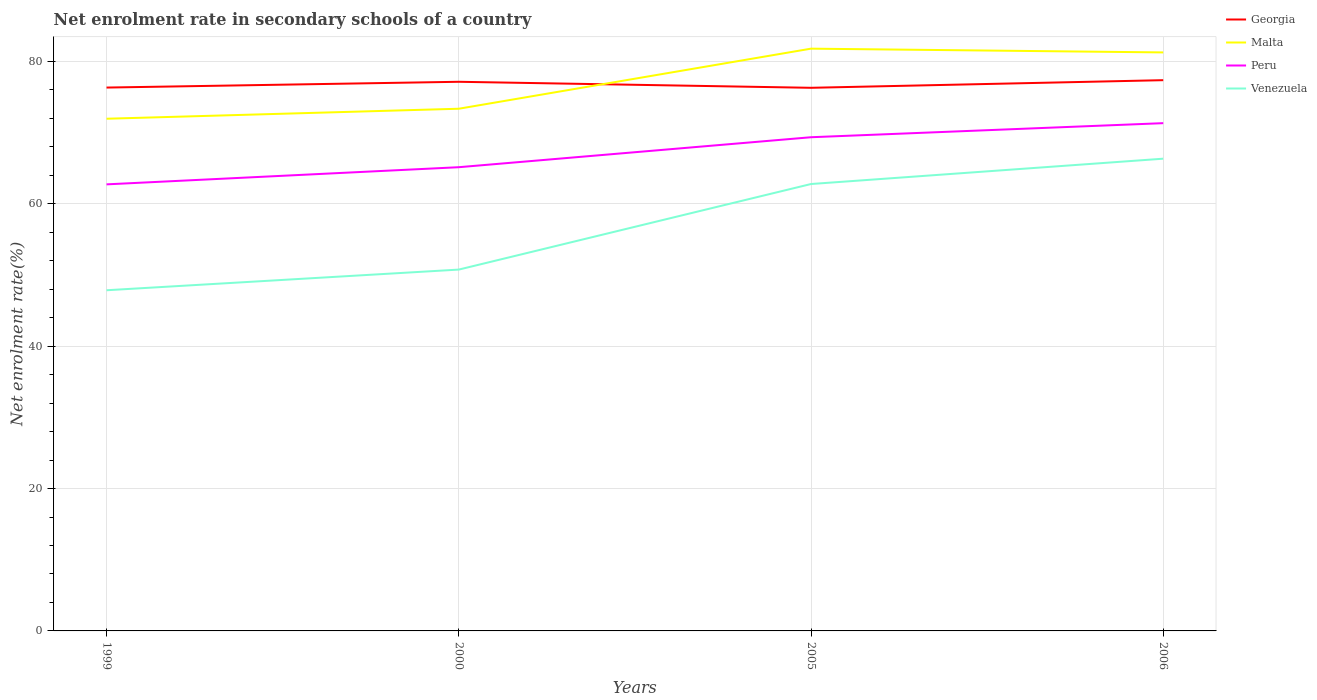How many different coloured lines are there?
Provide a short and direct response. 4. Does the line corresponding to Venezuela intersect with the line corresponding to Malta?
Your response must be concise. No. Across all years, what is the maximum net enrolment rate in secondary schools in Venezuela?
Offer a very short reply. 47.85. In which year was the net enrolment rate in secondary schools in Venezuela maximum?
Give a very brief answer. 1999. What is the total net enrolment rate in secondary schools in Malta in the graph?
Give a very brief answer. -8.44. What is the difference between the highest and the second highest net enrolment rate in secondary schools in Georgia?
Your response must be concise. 1.07. What is the difference between the highest and the lowest net enrolment rate in secondary schools in Georgia?
Your answer should be compact. 2. Is the net enrolment rate in secondary schools in Georgia strictly greater than the net enrolment rate in secondary schools in Malta over the years?
Offer a very short reply. No. Are the values on the major ticks of Y-axis written in scientific E-notation?
Offer a terse response. No. Does the graph contain any zero values?
Your answer should be compact. No. How are the legend labels stacked?
Keep it short and to the point. Vertical. What is the title of the graph?
Your answer should be very brief. Net enrolment rate in secondary schools of a country. Does "Rwanda" appear as one of the legend labels in the graph?
Ensure brevity in your answer.  No. What is the label or title of the X-axis?
Offer a terse response. Years. What is the label or title of the Y-axis?
Provide a short and direct response. Net enrolment rate(%). What is the Net enrolment rate(%) in Georgia in 1999?
Offer a very short reply. 76.32. What is the Net enrolment rate(%) of Malta in 1999?
Offer a very short reply. 71.94. What is the Net enrolment rate(%) in Peru in 1999?
Provide a succinct answer. 62.72. What is the Net enrolment rate(%) of Venezuela in 1999?
Provide a short and direct response. 47.85. What is the Net enrolment rate(%) in Georgia in 2000?
Make the answer very short. 77.13. What is the Net enrolment rate(%) of Malta in 2000?
Keep it short and to the point. 73.34. What is the Net enrolment rate(%) in Peru in 2000?
Keep it short and to the point. 65.13. What is the Net enrolment rate(%) of Venezuela in 2000?
Provide a short and direct response. 50.75. What is the Net enrolment rate(%) of Georgia in 2005?
Give a very brief answer. 76.28. What is the Net enrolment rate(%) in Malta in 2005?
Your answer should be very brief. 81.78. What is the Net enrolment rate(%) in Peru in 2005?
Provide a succinct answer. 69.34. What is the Net enrolment rate(%) in Venezuela in 2005?
Make the answer very short. 62.77. What is the Net enrolment rate(%) in Georgia in 2006?
Provide a short and direct response. 77.35. What is the Net enrolment rate(%) in Malta in 2006?
Make the answer very short. 81.25. What is the Net enrolment rate(%) in Peru in 2006?
Keep it short and to the point. 71.32. What is the Net enrolment rate(%) in Venezuela in 2006?
Your answer should be compact. 66.32. Across all years, what is the maximum Net enrolment rate(%) in Georgia?
Offer a terse response. 77.35. Across all years, what is the maximum Net enrolment rate(%) of Malta?
Offer a terse response. 81.78. Across all years, what is the maximum Net enrolment rate(%) in Peru?
Keep it short and to the point. 71.32. Across all years, what is the maximum Net enrolment rate(%) of Venezuela?
Your answer should be compact. 66.32. Across all years, what is the minimum Net enrolment rate(%) in Georgia?
Make the answer very short. 76.28. Across all years, what is the minimum Net enrolment rate(%) of Malta?
Offer a very short reply. 71.94. Across all years, what is the minimum Net enrolment rate(%) in Peru?
Keep it short and to the point. 62.72. Across all years, what is the minimum Net enrolment rate(%) in Venezuela?
Offer a very short reply. 47.85. What is the total Net enrolment rate(%) of Georgia in the graph?
Provide a succinct answer. 307.07. What is the total Net enrolment rate(%) of Malta in the graph?
Offer a very short reply. 308.31. What is the total Net enrolment rate(%) of Peru in the graph?
Offer a terse response. 268.5. What is the total Net enrolment rate(%) of Venezuela in the graph?
Your response must be concise. 227.69. What is the difference between the Net enrolment rate(%) in Georgia in 1999 and that in 2000?
Make the answer very short. -0.81. What is the difference between the Net enrolment rate(%) of Malta in 1999 and that in 2000?
Offer a very short reply. -1.41. What is the difference between the Net enrolment rate(%) of Peru in 1999 and that in 2000?
Keep it short and to the point. -2.41. What is the difference between the Net enrolment rate(%) of Venezuela in 1999 and that in 2000?
Your answer should be compact. -2.9. What is the difference between the Net enrolment rate(%) in Georgia in 1999 and that in 2005?
Offer a very short reply. 0.03. What is the difference between the Net enrolment rate(%) of Malta in 1999 and that in 2005?
Keep it short and to the point. -9.84. What is the difference between the Net enrolment rate(%) of Peru in 1999 and that in 2005?
Provide a short and direct response. -6.62. What is the difference between the Net enrolment rate(%) in Venezuela in 1999 and that in 2005?
Make the answer very short. -14.92. What is the difference between the Net enrolment rate(%) in Georgia in 1999 and that in 2006?
Your answer should be very brief. -1.04. What is the difference between the Net enrolment rate(%) of Malta in 1999 and that in 2006?
Ensure brevity in your answer.  -9.31. What is the difference between the Net enrolment rate(%) of Peru in 1999 and that in 2006?
Your answer should be compact. -8.6. What is the difference between the Net enrolment rate(%) of Venezuela in 1999 and that in 2006?
Make the answer very short. -18.48. What is the difference between the Net enrolment rate(%) of Georgia in 2000 and that in 2005?
Your response must be concise. 0.84. What is the difference between the Net enrolment rate(%) in Malta in 2000 and that in 2005?
Offer a very short reply. -8.44. What is the difference between the Net enrolment rate(%) of Peru in 2000 and that in 2005?
Your response must be concise. -4.21. What is the difference between the Net enrolment rate(%) in Venezuela in 2000 and that in 2005?
Ensure brevity in your answer.  -12.02. What is the difference between the Net enrolment rate(%) of Georgia in 2000 and that in 2006?
Give a very brief answer. -0.23. What is the difference between the Net enrolment rate(%) in Malta in 2000 and that in 2006?
Provide a succinct answer. -7.91. What is the difference between the Net enrolment rate(%) in Peru in 2000 and that in 2006?
Offer a very short reply. -6.19. What is the difference between the Net enrolment rate(%) of Venezuela in 2000 and that in 2006?
Make the answer very short. -15.58. What is the difference between the Net enrolment rate(%) in Georgia in 2005 and that in 2006?
Your answer should be very brief. -1.07. What is the difference between the Net enrolment rate(%) in Malta in 2005 and that in 2006?
Keep it short and to the point. 0.53. What is the difference between the Net enrolment rate(%) in Peru in 2005 and that in 2006?
Your response must be concise. -1.98. What is the difference between the Net enrolment rate(%) of Venezuela in 2005 and that in 2006?
Make the answer very short. -3.56. What is the difference between the Net enrolment rate(%) in Georgia in 1999 and the Net enrolment rate(%) in Malta in 2000?
Give a very brief answer. 2.97. What is the difference between the Net enrolment rate(%) of Georgia in 1999 and the Net enrolment rate(%) of Peru in 2000?
Ensure brevity in your answer.  11.19. What is the difference between the Net enrolment rate(%) of Georgia in 1999 and the Net enrolment rate(%) of Venezuela in 2000?
Provide a succinct answer. 25.57. What is the difference between the Net enrolment rate(%) of Malta in 1999 and the Net enrolment rate(%) of Peru in 2000?
Your answer should be compact. 6.81. What is the difference between the Net enrolment rate(%) of Malta in 1999 and the Net enrolment rate(%) of Venezuela in 2000?
Provide a succinct answer. 21.19. What is the difference between the Net enrolment rate(%) of Peru in 1999 and the Net enrolment rate(%) of Venezuela in 2000?
Provide a succinct answer. 11.97. What is the difference between the Net enrolment rate(%) of Georgia in 1999 and the Net enrolment rate(%) of Malta in 2005?
Offer a very short reply. -5.46. What is the difference between the Net enrolment rate(%) in Georgia in 1999 and the Net enrolment rate(%) in Peru in 2005?
Make the answer very short. 6.98. What is the difference between the Net enrolment rate(%) of Georgia in 1999 and the Net enrolment rate(%) of Venezuela in 2005?
Offer a terse response. 13.55. What is the difference between the Net enrolment rate(%) in Malta in 1999 and the Net enrolment rate(%) in Peru in 2005?
Your response must be concise. 2.6. What is the difference between the Net enrolment rate(%) of Malta in 1999 and the Net enrolment rate(%) of Venezuela in 2005?
Keep it short and to the point. 9.17. What is the difference between the Net enrolment rate(%) in Peru in 1999 and the Net enrolment rate(%) in Venezuela in 2005?
Your answer should be compact. -0.05. What is the difference between the Net enrolment rate(%) of Georgia in 1999 and the Net enrolment rate(%) of Malta in 2006?
Provide a short and direct response. -4.93. What is the difference between the Net enrolment rate(%) in Georgia in 1999 and the Net enrolment rate(%) in Peru in 2006?
Provide a short and direct response. 5. What is the difference between the Net enrolment rate(%) in Georgia in 1999 and the Net enrolment rate(%) in Venezuela in 2006?
Your answer should be very brief. 9.99. What is the difference between the Net enrolment rate(%) in Malta in 1999 and the Net enrolment rate(%) in Peru in 2006?
Give a very brief answer. 0.62. What is the difference between the Net enrolment rate(%) of Malta in 1999 and the Net enrolment rate(%) of Venezuela in 2006?
Offer a very short reply. 5.61. What is the difference between the Net enrolment rate(%) of Peru in 1999 and the Net enrolment rate(%) of Venezuela in 2006?
Your answer should be compact. -3.61. What is the difference between the Net enrolment rate(%) in Georgia in 2000 and the Net enrolment rate(%) in Malta in 2005?
Ensure brevity in your answer.  -4.65. What is the difference between the Net enrolment rate(%) of Georgia in 2000 and the Net enrolment rate(%) of Peru in 2005?
Offer a terse response. 7.79. What is the difference between the Net enrolment rate(%) in Georgia in 2000 and the Net enrolment rate(%) in Venezuela in 2005?
Give a very brief answer. 14.36. What is the difference between the Net enrolment rate(%) in Malta in 2000 and the Net enrolment rate(%) in Peru in 2005?
Your answer should be very brief. 4. What is the difference between the Net enrolment rate(%) in Malta in 2000 and the Net enrolment rate(%) in Venezuela in 2005?
Your response must be concise. 10.57. What is the difference between the Net enrolment rate(%) of Peru in 2000 and the Net enrolment rate(%) of Venezuela in 2005?
Keep it short and to the point. 2.36. What is the difference between the Net enrolment rate(%) of Georgia in 2000 and the Net enrolment rate(%) of Malta in 2006?
Make the answer very short. -4.12. What is the difference between the Net enrolment rate(%) in Georgia in 2000 and the Net enrolment rate(%) in Peru in 2006?
Your answer should be very brief. 5.81. What is the difference between the Net enrolment rate(%) in Georgia in 2000 and the Net enrolment rate(%) in Venezuela in 2006?
Your response must be concise. 10.8. What is the difference between the Net enrolment rate(%) of Malta in 2000 and the Net enrolment rate(%) of Peru in 2006?
Offer a very short reply. 2.03. What is the difference between the Net enrolment rate(%) in Malta in 2000 and the Net enrolment rate(%) in Venezuela in 2006?
Make the answer very short. 7.02. What is the difference between the Net enrolment rate(%) in Peru in 2000 and the Net enrolment rate(%) in Venezuela in 2006?
Give a very brief answer. -1.2. What is the difference between the Net enrolment rate(%) of Georgia in 2005 and the Net enrolment rate(%) of Malta in 2006?
Your answer should be very brief. -4.97. What is the difference between the Net enrolment rate(%) of Georgia in 2005 and the Net enrolment rate(%) of Peru in 2006?
Make the answer very short. 4.97. What is the difference between the Net enrolment rate(%) in Georgia in 2005 and the Net enrolment rate(%) in Venezuela in 2006?
Provide a succinct answer. 9.96. What is the difference between the Net enrolment rate(%) of Malta in 2005 and the Net enrolment rate(%) of Peru in 2006?
Offer a terse response. 10.46. What is the difference between the Net enrolment rate(%) of Malta in 2005 and the Net enrolment rate(%) of Venezuela in 2006?
Give a very brief answer. 15.45. What is the difference between the Net enrolment rate(%) in Peru in 2005 and the Net enrolment rate(%) in Venezuela in 2006?
Ensure brevity in your answer.  3.01. What is the average Net enrolment rate(%) of Georgia per year?
Make the answer very short. 76.77. What is the average Net enrolment rate(%) of Malta per year?
Make the answer very short. 77.08. What is the average Net enrolment rate(%) in Peru per year?
Ensure brevity in your answer.  67.13. What is the average Net enrolment rate(%) in Venezuela per year?
Your response must be concise. 56.92. In the year 1999, what is the difference between the Net enrolment rate(%) of Georgia and Net enrolment rate(%) of Malta?
Your response must be concise. 4.38. In the year 1999, what is the difference between the Net enrolment rate(%) of Georgia and Net enrolment rate(%) of Peru?
Give a very brief answer. 13.6. In the year 1999, what is the difference between the Net enrolment rate(%) in Georgia and Net enrolment rate(%) in Venezuela?
Provide a short and direct response. 28.47. In the year 1999, what is the difference between the Net enrolment rate(%) in Malta and Net enrolment rate(%) in Peru?
Ensure brevity in your answer.  9.22. In the year 1999, what is the difference between the Net enrolment rate(%) in Malta and Net enrolment rate(%) in Venezuela?
Offer a terse response. 24.09. In the year 1999, what is the difference between the Net enrolment rate(%) in Peru and Net enrolment rate(%) in Venezuela?
Your answer should be very brief. 14.87. In the year 2000, what is the difference between the Net enrolment rate(%) of Georgia and Net enrolment rate(%) of Malta?
Provide a short and direct response. 3.78. In the year 2000, what is the difference between the Net enrolment rate(%) in Georgia and Net enrolment rate(%) in Peru?
Your response must be concise. 12. In the year 2000, what is the difference between the Net enrolment rate(%) in Georgia and Net enrolment rate(%) in Venezuela?
Your answer should be very brief. 26.38. In the year 2000, what is the difference between the Net enrolment rate(%) in Malta and Net enrolment rate(%) in Peru?
Your answer should be very brief. 8.21. In the year 2000, what is the difference between the Net enrolment rate(%) of Malta and Net enrolment rate(%) of Venezuela?
Offer a terse response. 22.59. In the year 2000, what is the difference between the Net enrolment rate(%) of Peru and Net enrolment rate(%) of Venezuela?
Your answer should be very brief. 14.38. In the year 2005, what is the difference between the Net enrolment rate(%) in Georgia and Net enrolment rate(%) in Malta?
Your answer should be very brief. -5.5. In the year 2005, what is the difference between the Net enrolment rate(%) of Georgia and Net enrolment rate(%) of Peru?
Give a very brief answer. 6.94. In the year 2005, what is the difference between the Net enrolment rate(%) of Georgia and Net enrolment rate(%) of Venezuela?
Ensure brevity in your answer.  13.52. In the year 2005, what is the difference between the Net enrolment rate(%) of Malta and Net enrolment rate(%) of Peru?
Your response must be concise. 12.44. In the year 2005, what is the difference between the Net enrolment rate(%) in Malta and Net enrolment rate(%) in Venezuela?
Your answer should be compact. 19.01. In the year 2005, what is the difference between the Net enrolment rate(%) in Peru and Net enrolment rate(%) in Venezuela?
Give a very brief answer. 6.57. In the year 2006, what is the difference between the Net enrolment rate(%) in Georgia and Net enrolment rate(%) in Malta?
Provide a short and direct response. -3.9. In the year 2006, what is the difference between the Net enrolment rate(%) in Georgia and Net enrolment rate(%) in Peru?
Offer a very short reply. 6.04. In the year 2006, what is the difference between the Net enrolment rate(%) of Georgia and Net enrolment rate(%) of Venezuela?
Offer a terse response. 11.03. In the year 2006, what is the difference between the Net enrolment rate(%) of Malta and Net enrolment rate(%) of Peru?
Your answer should be compact. 9.93. In the year 2006, what is the difference between the Net enrolment rate(%) in Malta and Net enrolment rate(%) in Venezuela?
Make the answer very short. 14.92. In the year 2006, what is the difference between the Net enrolment rate(%) in Peru and Net enrolment rate(%) in Venezuela?
Provide a short and direct response. 4.99. What is the ratio of the Net enrolment rate(%) of Georgia in 1999 to that in 2000?
Your response must be concise. 0.99. What is the ratio of the Net enrolment rate(%) in Malta in 1999 to that in 2000?
Offer a very short reply. 0.98. What is the ratio of the Net enrolment rate(%) of Peru in 1999 to that in 2000?
Provide a short and direct response. 0.96. What is the ratio of the Net enrolment rate(%) of Venezuela in 1999 to that in 2000?
Give a very brief answer. 0.94. What is the ratio of the Net enrolment rate(%) in Malta in 1999 to that in 2005?
Keep it short and to the point. 0.88. What is the ratio of the Net enrolment rate(%) of Peru in 1999 to that in 2005?
Your answer should be very brief. 0.9. What is the ratio of the Net enrolment rate(%) of Venezuela in 1999 to that in 2005?
Ensure brevity in your answer.  0.76. What is the ratio of the Net enrolment rate(%) in Georgia in 1999 to that in 2006?
Provide a succinct answer. 0.99. What is the ratio of the Net enrolment rate(%) of Malta in 1999 to that in 2006?
Offer a very short reply. 0.89. What is the ratio of the Net enrolment rate(%) in Peru in 1999 to that in 2006?
Offer a very short reply. 0.88. What is the ratio of the Net enrolment rate(%) in Venezuela in 1999 to that in 2006?
Provide a short and direct response. 0.72. What is the ratio of the Net enrolment rate(%) in Georgia in 2000 to that in 2005?
Your answer should be very brief. 1.01. What is the ratio of the Net enrolment rate(%) in Malta in 2000 to that in 2005?
Offer a very short reply. 0.9. What is the ratio of the Net enrolment rate(%) of Peru in 2000 to that in 2005?
Offer a terse response. 0.94. What is the ratio of the Net enrolment rate(%) in Venezuela in 2000 to that in 2005?
Provide a short and direct response. 0.81. What is the ratio of the Net enrolment rate(%) in Georgia in 2000 to that in 2006?
Provide a short and direct response. 1. What is the ratio of the Net enrolment rate(%) in Malta in 2000 to that in 2006?
Your answer should be very brief. 0.9. What is the ratio of the Net enrolment rate(%) in Peru in 2000 to that in 2006?
Keep it short and to the point. 0.91. What is the ratio of the Net enrolment rate(%) in Venezuela in 2000 to that in 2006?
Provide a succinct answer. 0.77. What is the ratio of the Net enrolment rate(%) of Georgia in 2005 to that in 2006?
Make the answer very short. 0.99. What is the ratio of the Net enrolment rate(%) of Peru in 2005 to that in 2006?
Give a very brief answer. 0.97. What is the ratio of the Net enrolment rate(%) in Venezuela in 2005 to that in 2006?
Your response must be concise. 0.95. What is the difference between the highest and the second highest Net enrolment rate(%) in Georgia?
Your answer should be very brief. 0.23. What is the difference between the highest and the second highest Net enrolment rate(%) of Malta?
Your response must be concise. 0.53. What is the difference between the highest and the second highest Net enrolment rate(%) in Peru?
Make the answer very short. 1.98. What is the difference between the highest and the second highest Net enrolment rate(%) in Venezuela?
Ensure brevity in your answer.  3.56. What is the difference between the highest and the lowest Net enrolment rate(%) of Georgia?
Provide a short and direct response. 1.07. What is the difference between the highest and the lowest Net enrolment rate(%) in Malta?
Keep it short and to the point. 9.84. What is the difference between the highest and the lowest Net enrolment rate(%) of Peru?
Your response must be concise. 8.6. What is the difference between the highest and the lowest Net enrolment rate(%) of Venezuela?
Make the answer very short. 18.48. 